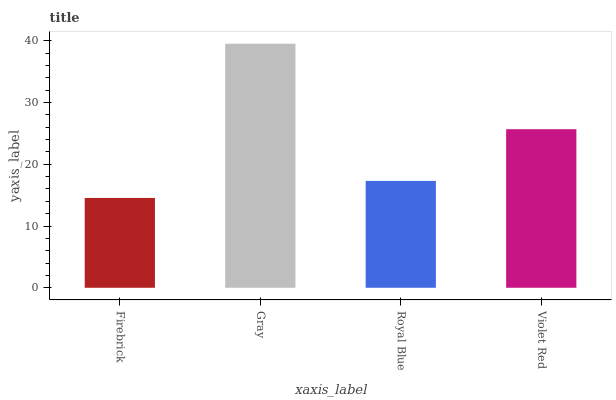Is Firebrick the minimum?
Answer yes or no. Yes. Is Gray the maximum?
Answer yes or no. Yes. Is Royal Blue the minimum?
Answer yes or no. No. Is Royal Blue the maximum?
Answer yes or no. No. Is Gray greater than Royal Blue?
Answer yes or no. Yes. Is Royal Blue less than Gray?
Answer yes or no. Yes. Is Royal Blue greater than Gray?
Answer yes or no. No. Is Gray less than Royal Blue?
Answer yes or no. No. Is Violet Red the high median?
Answer yes or no. Yes. Is Royal Blue the low median?
Answer yes or no. Yes. Is Royal Blue the high median?
Answer yes or no. No. Is Firebrick the low median?
Answer yes or no. No. 